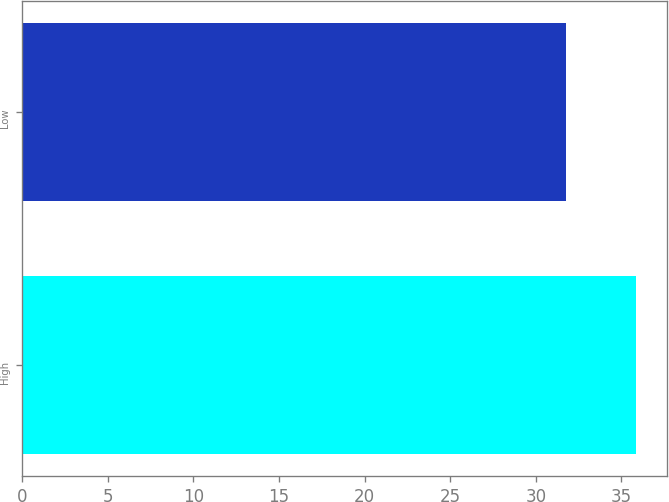Convert chart. <chart><loc_0><loc_0><loc_500><loc_500><bar_chart><fcel>High<fcel>Low<nl><fcel>35.86<fcel>31.74<nl></chart> 